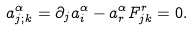<formula> <loc_0><loc_0><loc_500><loc_500>a ^ { \alpha } _ { j ; k } = \partial _ { j } a ^ { \alpha } _ { i } - a ^ { \alpha } _ { r } F ^ { r } _ { j k } = 0 .</formula> 